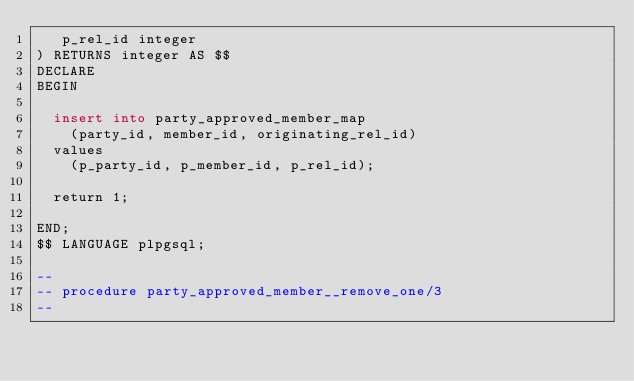Convert code to text. <code><loc_0><loc_0><loc_500><loc_500><_SQL_>   p_rel_id integer
) RETURNS integer AS $$
DECLARE
BEGIN

  insert into party_approved_member_map
    (party_id, member_id, originating_rel_id)
  values
    (p_party_id, p_member_id, p_rel_id);

  return 1;

END;
$$ LANGUAGE plpgsql;

--
-- procedure party_approved_member__remove_one/3
--</code> 